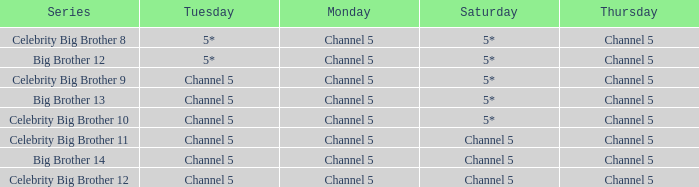Which Thursday does big brother 13 air? Channel 5. 